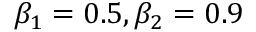<formula> <loc_0><loc_0><loc_500><loc_500>\beta _ { 1 } = 0 . 5 , \beta _ { 2 } = 0 . 9</formula> 